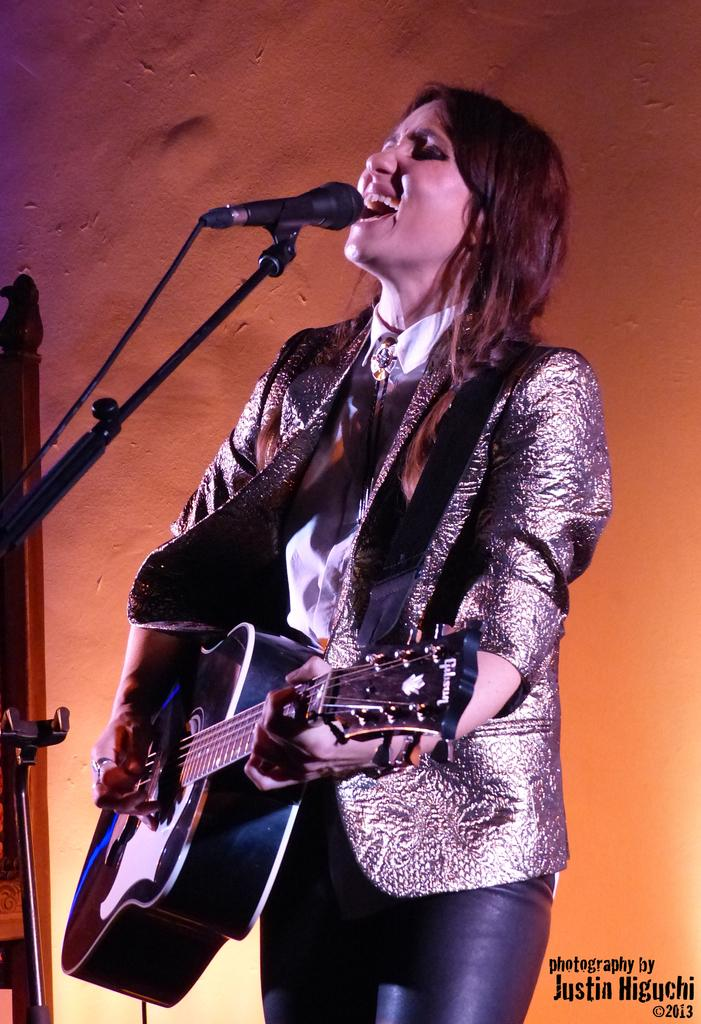Who is the main subject in the image? There is a woman in the image. What is the woman doing in the image? The woman is singing in the image. What objects is the woman holding in the image? The woman is holding a microphone and a guitar in the image. What type of pot is visible in the image? There is no pot present in the image. What material is the brass used for in the image? There is no brass present in the image. 